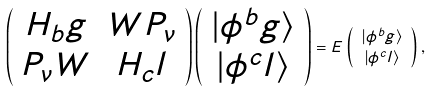<formula> <loc_0><loc_0><loc_500><loc_500>\left ( \begin{array} { c c } H _ { b } g & W P _ { \nu } \\ P _ { \nu } W & H _ { c } l \end{array} \right ) \left ( \begin{array} { c } | \phi ^ { b } g \rangle \\ | \phi ^ { c } l \rangle \end{array} \right ) & = E \left ( \begin{array} { c } | \phi ^ { b } g \rangle \\ | \phi ^ { c } l \rangle \end{array} \right ) ,</formula> 